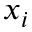Convert formula to latex. <formula><loc_0><loc_0><loc_500><loc_500>x _ { i }</formula> 